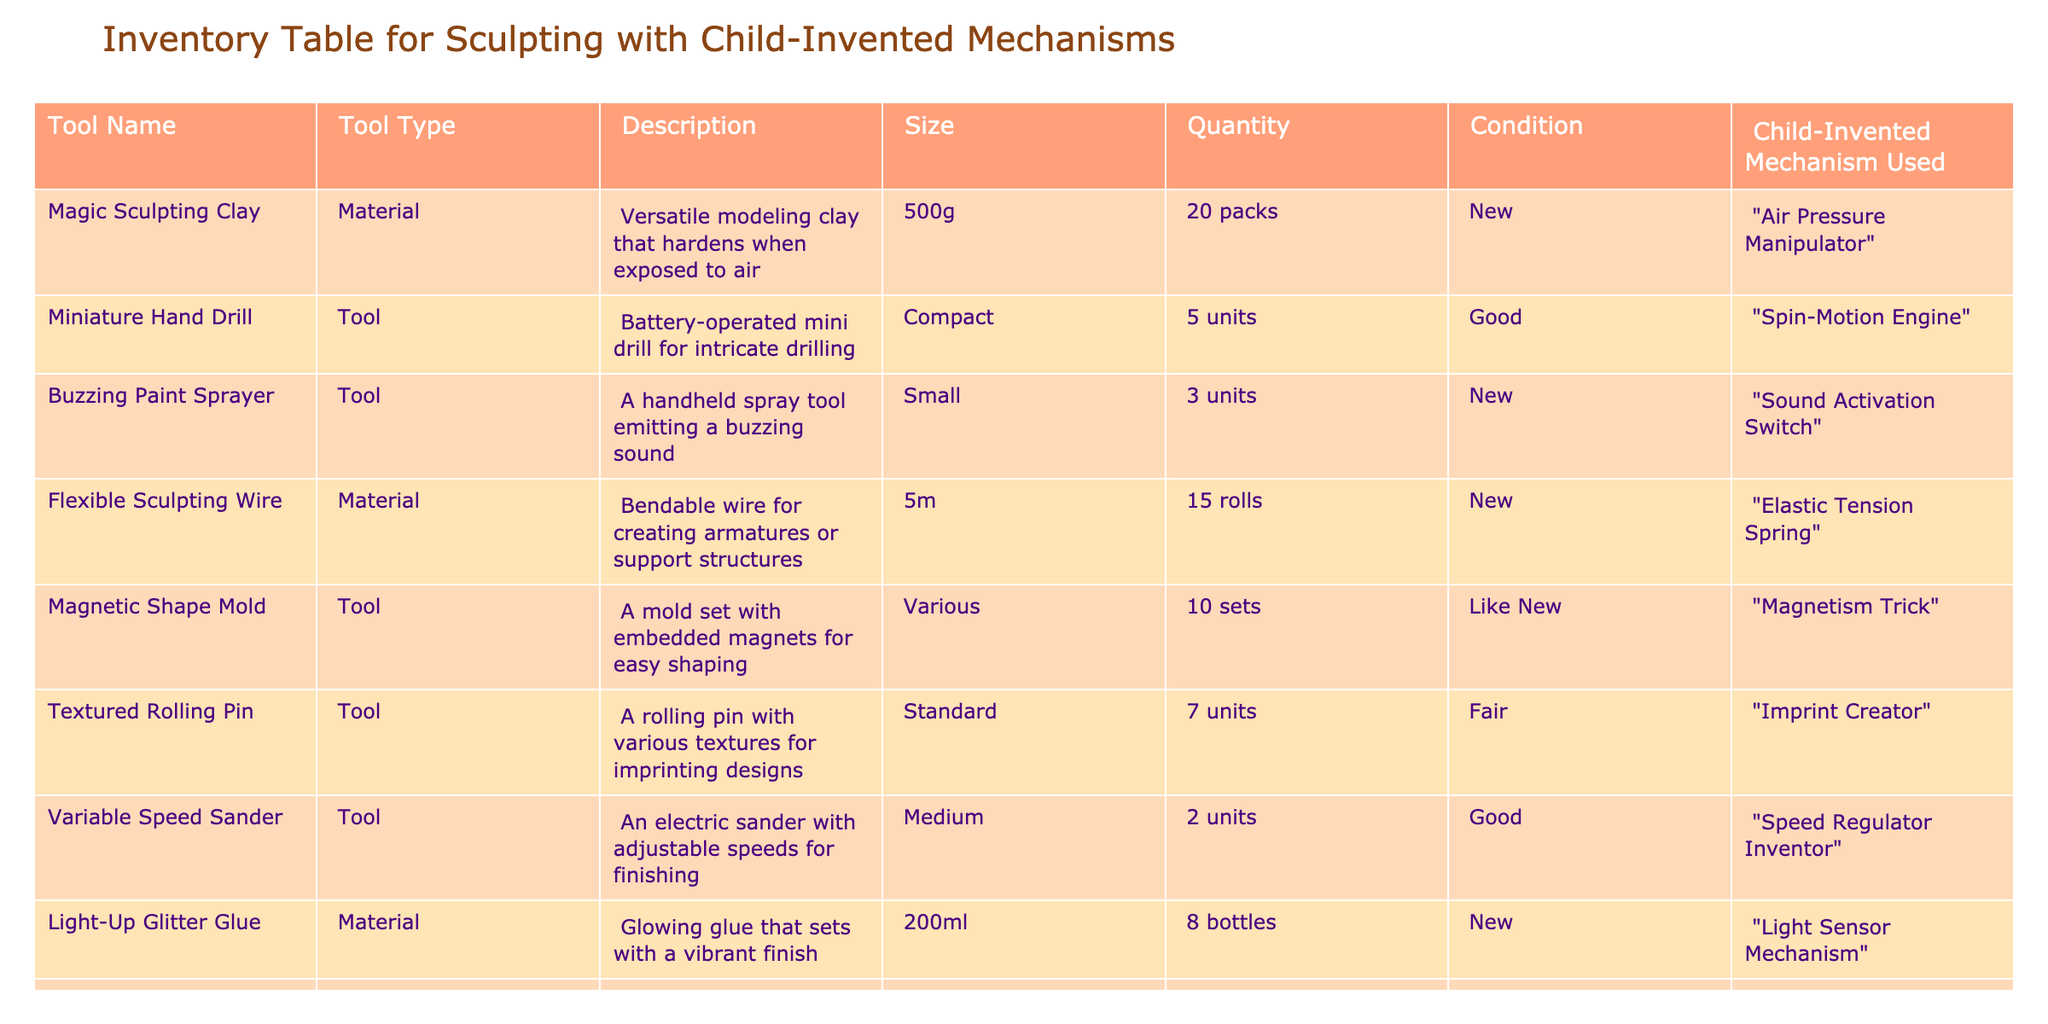What is the total quantity of "Child-Safe Cutting Tool" available in the inventory? The table lists the "Child-Safe Cutting Tool" under the Quantity column, which states there are 10 units available.
Answer: 10 How many tools are in "Fair" condition? In the table, only the "Textured Rolling Pin" is listed as being in "Fair" condition. Therefore, there is 1 tool in this condition.
Answer: 1 Which tool uses "Safety Enhancer" as its child-invented mechanism? There is one tool listed in the table that uses "Safety Enhancer," which is the "Child-Safe Cutting Tool."
Answer: Child-Safe Cutting Tool What is the sum of the quantities of all tools listed in the table? The individual quantities are 20 packs, 5 units, 3 units, 15 rolls, 10 sets, 7 units, 2 units, 8 bottles, 10 units, and 12 sets. Summing them gives 20 + 5 + 3 + 15 + 10 + 7 + 2 + 8 + 10 + 12 = 92.
Answer: 92 Is there any tool listed that has a "Like New" condition? Yes, the "Magnetic Shape Mold" is listed with a "Like New" condition in the table.
Answer: Yes What is the average size of the tools in the inventory? The sizes are 500g, Compact, Small, 5m, Various, Standard, Medium, 200ml, Small, Various. Since there are various categories of sizes, calculating an average isn't applicable; hence, no average size can be provided.
Answer: Not applicable Which material has the highest quantity? The "Magic Sculpting Clay" has 20 packs, which is more than the other materials, which have 15 rolls and 8 bottles. Thus, it has the highest quantity.
Answer: Magic Sculpting Clay Are there more units of tools than materials in the inventory? There are 5 tools and 3 materials listed. The count of tools (8 units) is greater than the materials (3).
Answer: Yes What is the condition of the "Variable Speed Sander"? The table lists "Variable Speed Sander" as being in "Good" condition. Therefore, that is the overall evaluation of its state.
Answer: Good 